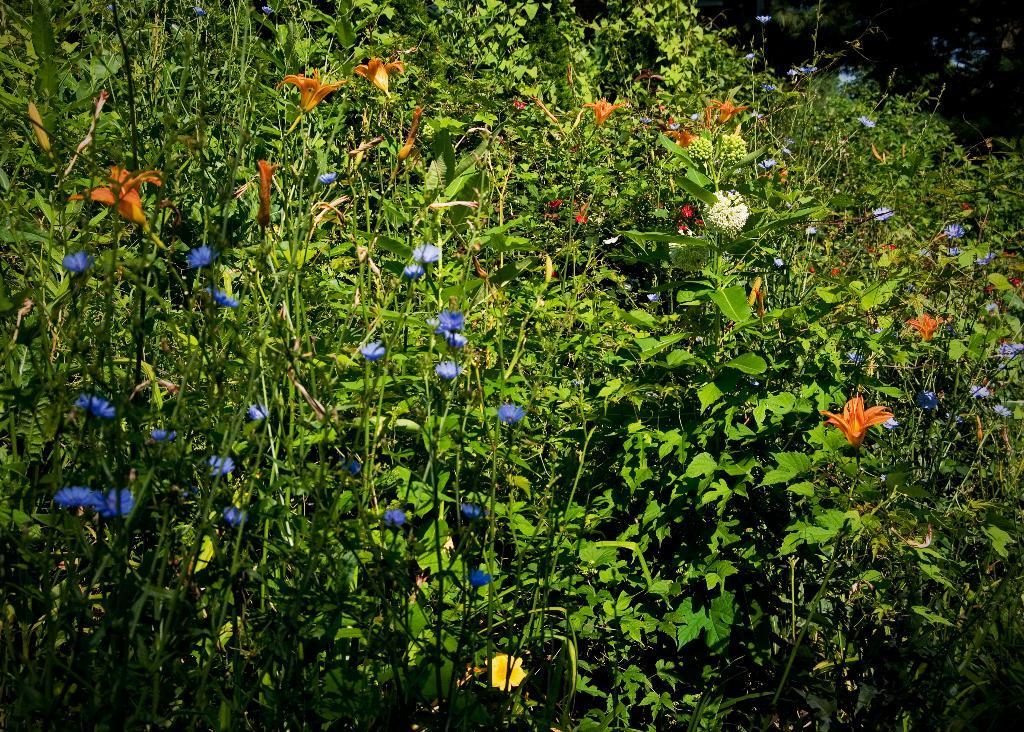What type of living organisms can be seen in the image? Plants and flowers are visible in the image. Can you describe the flowers in the image? The flowers in the image are part of the plants and add color and beauty to the scene. What type of fiction is the queen reading in the image? There is no queen or fiction present in the image; it features plants and flowers. 